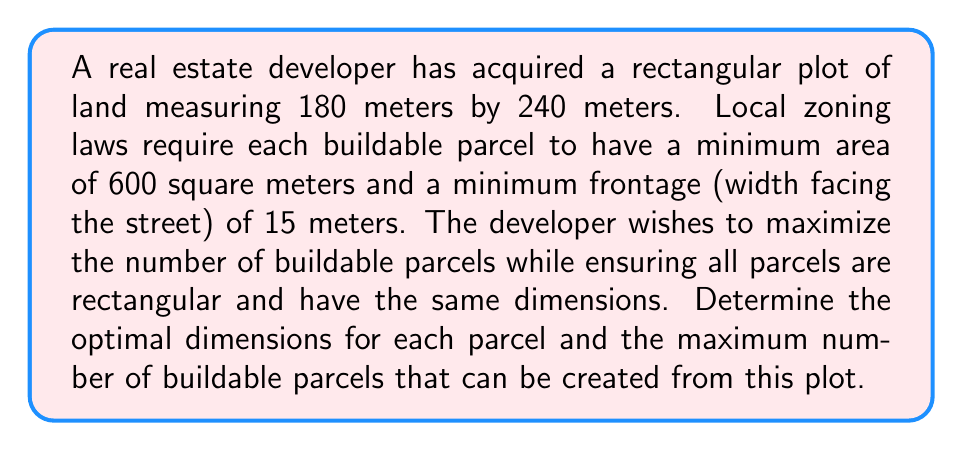Could you help me with this problem? To solve this problem, we need to consider the constraints and optimize the parcel dimensions. Let's approach this step-by-step:

1) Let the width of each parcel be $w$ meters and the depth be $d$ meters.

2) Given the plot dimensions and zoning requirements:
   - Total width available: 180 meters
   - Total depth available: 240 meters
   - Minimum area per parcel: 600 sq meters
   - Minimum frontage (width): 15 meters

3) The area constraint gives us:
   $$ w \times d \geq 600 $$

4) The number of parcels across the width of the plot must be an integer:
   $$ \frac{180}{w} = \text{integer} $$

5) Similarly, for the depth:
   $$ \frac{240}{d} = \text{integer} $$

6) The total number of parcels will be:
   $$ N = \frac{180}{w} \times \frac{240}{d} = \frac{43200}{wd} $$

7) To maximize N, we need to minimize $wd$ while satisfying all constraints.

8) The smallest possible $w$ is 15 meters (due to the frontage requirement).

9) With $w = 15$, we can have 12 parcels across the width (180 ÷ 15 = 12).

10) For the depth, we need:
    $$ 15d \geq 600 $$
    $$ d \geq 40 $$

11) The largest number of parcels in the depth direction that satisfies this is:
    $$ \frac{240}{40} = 6 $$

12) Therefore, the optimal dimensions are:
    - Width (w) = 15 meters
    - Depth (d) = 40 meters

13) The total number of parcels is:
    $$ N = 12 \times 6 = 72 $$

This configuration maximizes the number of buildable parcels while satisfying all given constraints.
Answer: The optimal dimensions for each parcel are 15 meters wide by 40 meters deep, yielding a maximum of 72 buildable parcels. 